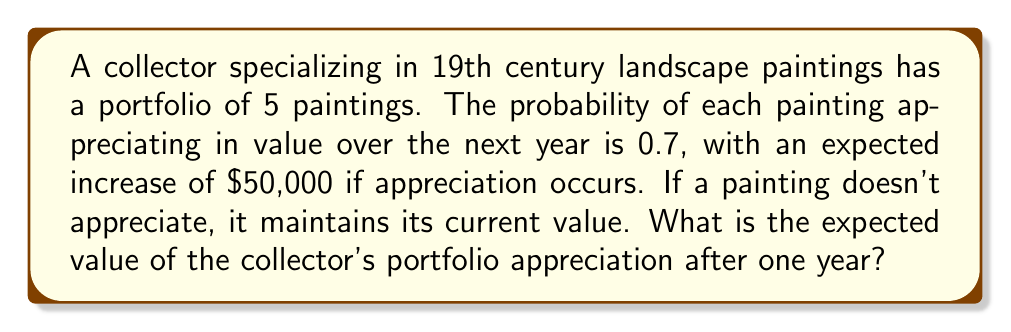Help me with this question. Let's approach this step-by-step:

1) First, we need to calculate the expected value of appreciation for a single painting:

   Let $X$ be the random variable representing the appreciation of a single painting.
   
   $P(X = 50000) = 0.7$ (probability of appreciating)
   $P(X = 0) = 0.3$ (probability of not appreciating)

   The expected value $E(X)$ is:
   
   $E(X) = 50000 \cdot 0.7 + 0 \cdot 0.3 = 35000$

2) Now, since there are 5 paintings in the portfolio, and each painting's appreciation is independent, we can multiply the expected value of one painting by 5:

   Let $Y$ be the random variable representing the total appreciation of the portfolio.
   
   $E(Y) = 5 \cdot E(X) = 5 \cdot 35000 = 175000$

Therefore, the expected value of the portfolio's appreciation after one year is $175,000.
Answer: $175,000 